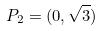<formula> <loc_0><loc_0><loc_500><loc_500>P _ { 2 } = ( 0 , \sqrt { 3 } )</formula> 